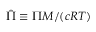<formula> <loc_0><loc_0><loc_500><loc_500>\hat { \Pi } \equiv \Pi M / ( c R T )</formula> 